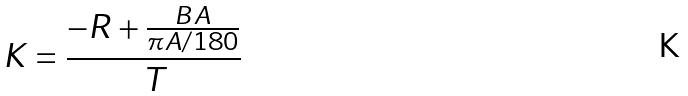<formula> <loc_0><loc_0><loc_500><loc_500>K = \frac { - R + \frac { B A } { \pi A / 1 8 0 } } { T }</formula> 